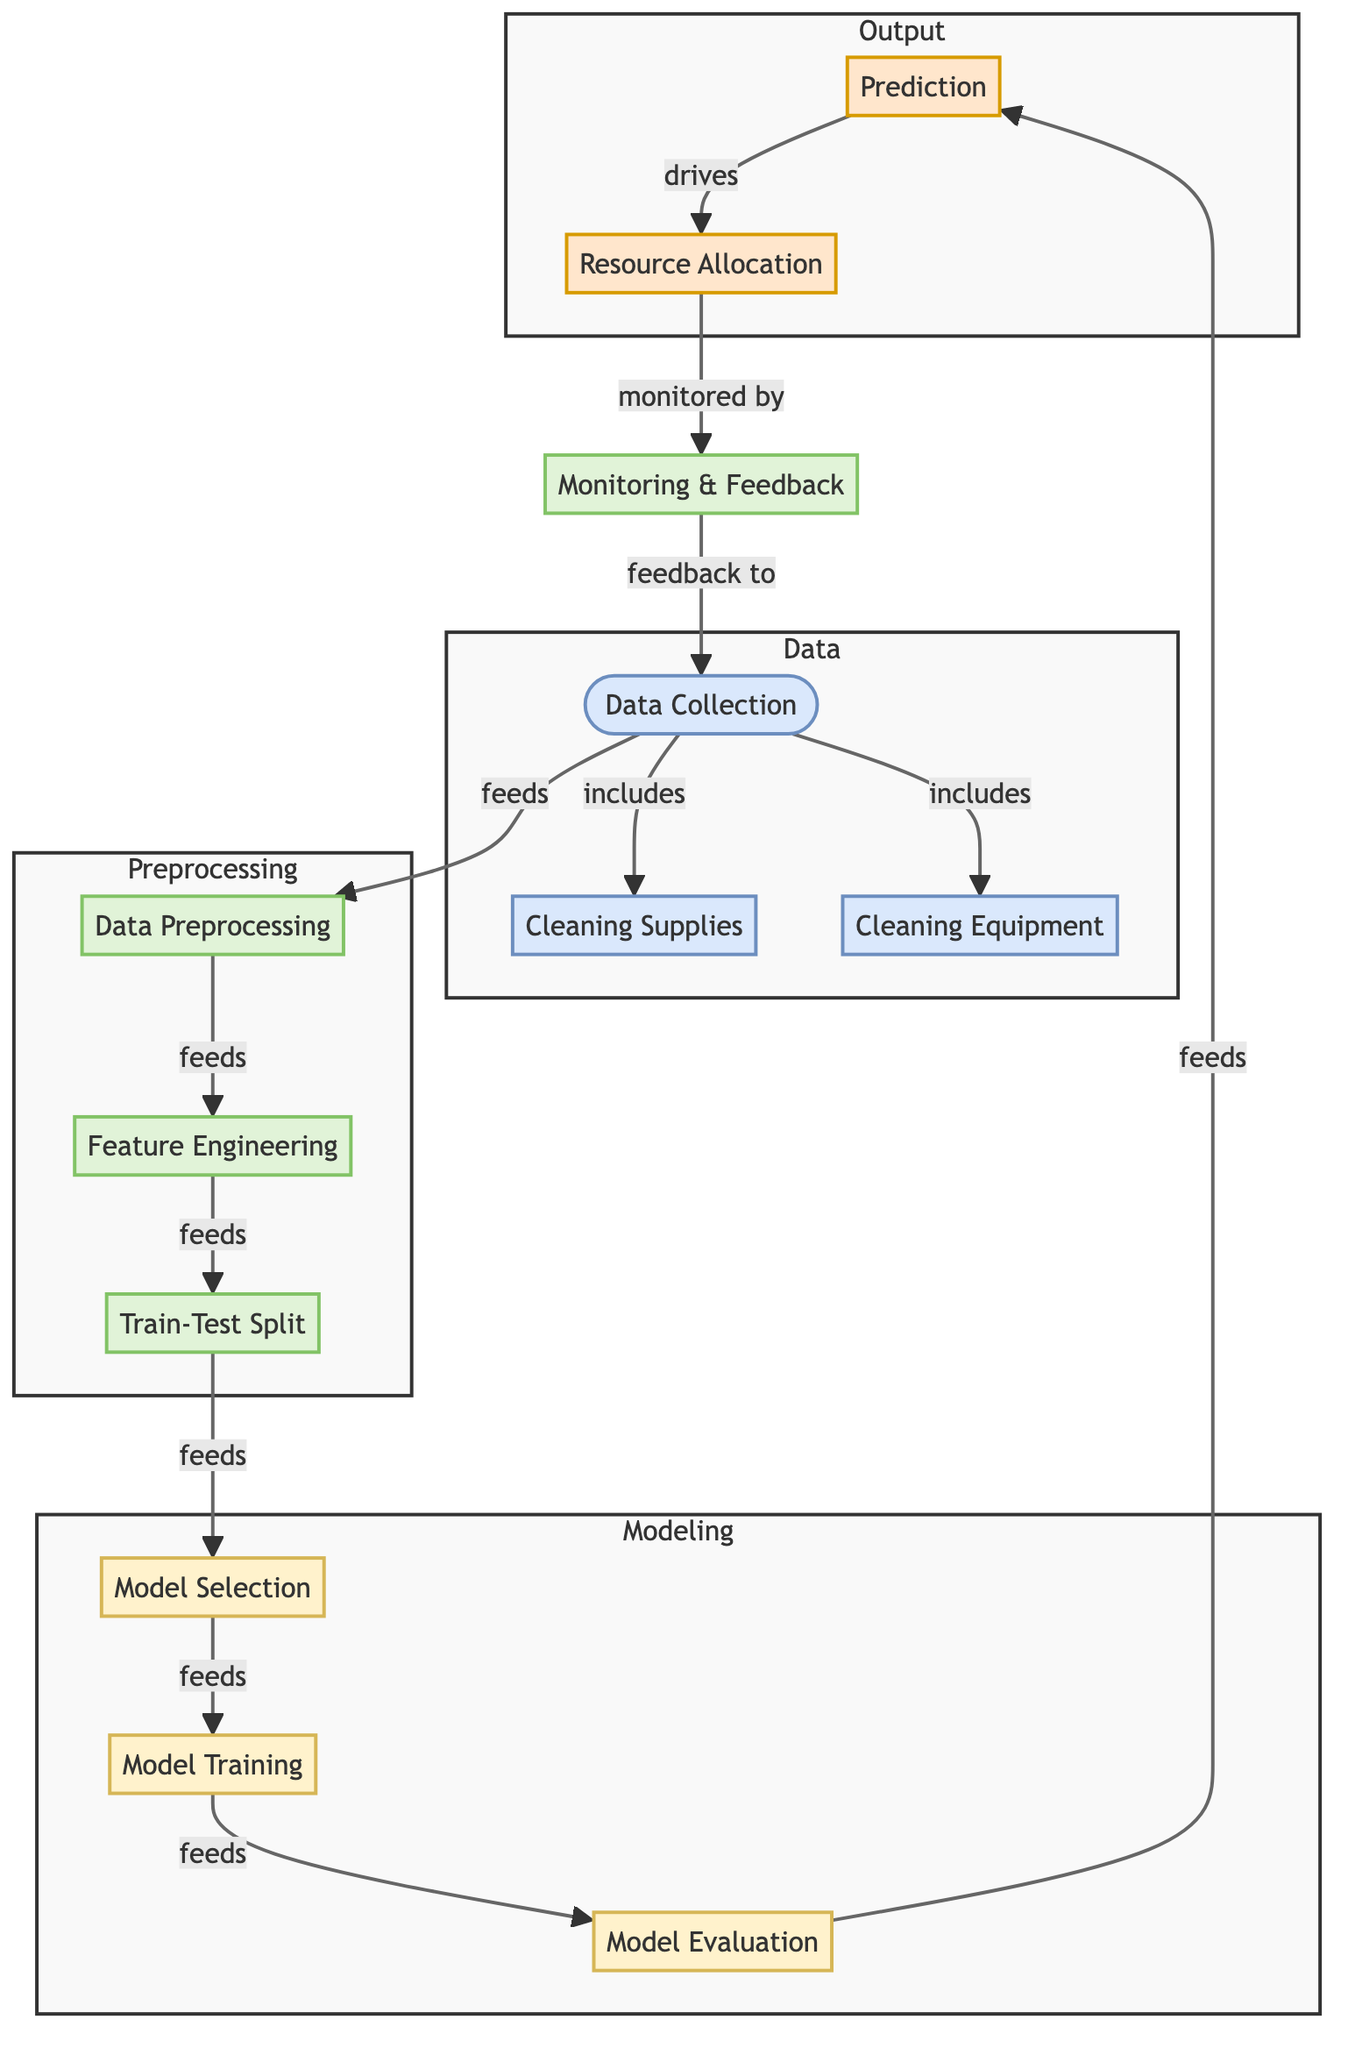what are the three main categories in the diagram? The diagram is organized into four main categories: Data, Preprocessing, Modeling, and Output, which are visually represented with distinct subgraph sections. The three specified categories in the context asked refer to Data, Preprocessing, and Modeling.
Answer: Data, Preprocessing, Modeling how many nodes are there in the diagram? The diagram contains a total of fourteen nodes as listed visually: three data nodes, four preprocessing nodes, three modeling nodes, and two output nodes.
Answer: fourteen which process comes after data preprocessing? Following data preprocessing in the flow, the next process is feature engineering, as indicated by the directional flow in the diagram.
Answer: feature engineering what type of node is 'model evaluation'? In the diagram, 'model evaluation' is classified as a model type node, as denoted by the specific coloring and labeling associated with it in the diagram's model category.
Answer: model how does resource allocation connect with prediction? The connection between 'resource allocation' and 'prediction' is established as output, indicated by a directional arrow in the diagram that shows that 'prediction' drives 'resource allocation'.
Answer: drives what is monitored by the monitoring & feedback node? The monitoring & feedback node is responsible for monitoring the 'resource allocation', according to the directional relationship illustrated in the diagram.
Answer: resource allocation which two nodes feed into model selection? The two nodes that feed into 'model selection' are 'train-test split' and 'feature engineering', as indicated by arrows showing their directional flow into the model selection node.
Answer: feature engineering, train-test split what does monitoring & feedback provide to data collection? Monitoring & feedback provides feedback to 'data collection', forming a loop of improvement based on the observations and assessments made after resource allocation.
Answer: feedback to what type of node is 'train-test split'? 'Train-test split' is categorized as a process node, as reflected in the diagram's structure and coloring that identifies it distinctly from data and model nodes.
Answer: process 